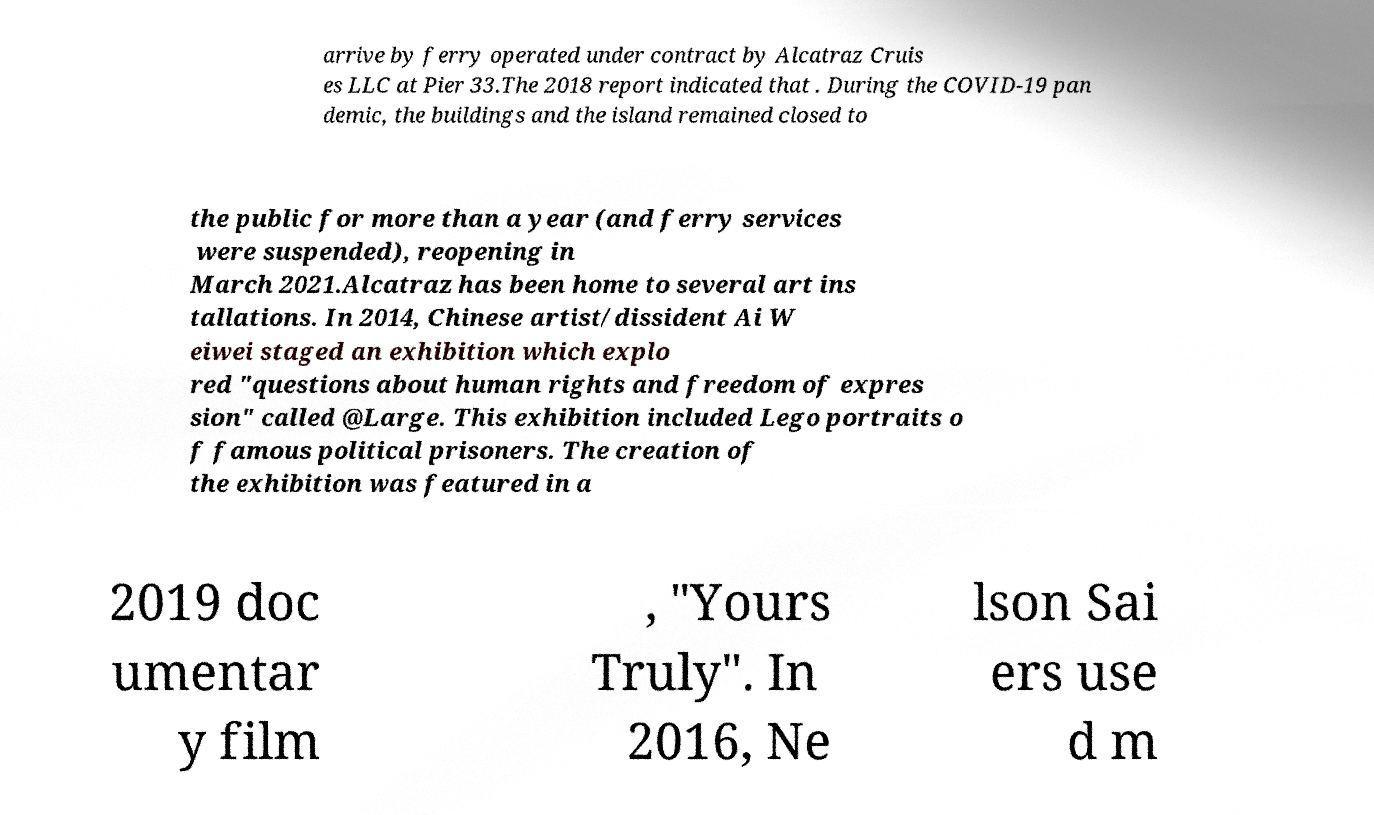There's text embedded in this image that I need extracted. Can you transcribe it verbatim? arrive by ferry operated under contract by Alcatraz Cruis es LLC at Pier 33.The 2018 report indicated that . During the COVID-19 pan demic, the buildings and the island remained closed to the public for more than a year (and ferry services were suspended), reopening in March 2021.Alcatraz has been home to several art ins tallations. In 2014, Chinese artist/dissident Ai W eiwei staged an exhibition which explo red "questions about human rights and freedom of expres sion" called @Large. This exhibition included Lego portraits o f famous political prisoners. The creation of the exhibition was featured in a 2019 doc umentar y film , "Yours Truly". In 2016, Ne lson Sai ers use d m 